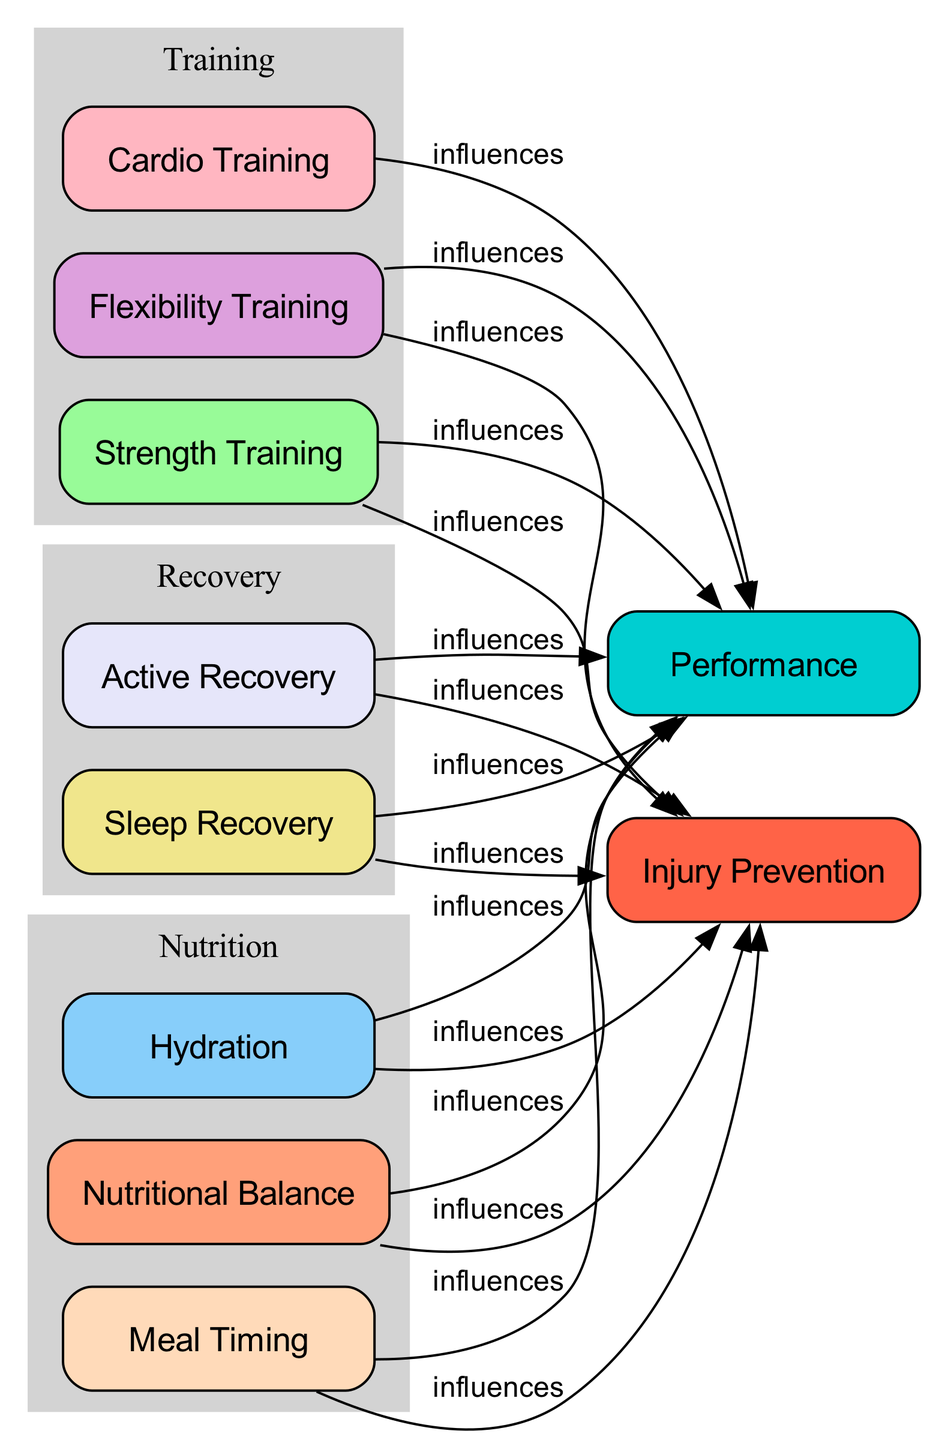What is the total number of nodes in the diagram? By counting each unique item listed under the nodes section, we find there are 10 distinct nodes representing various aspects of health and nutrition for athletes.
Answer: 10 Which node influences Performance the most? All nodes are connected to the Performance node; however, there is no node that influences it more than others as each node has a direct edge to it.
Answer: All nodes How many edges are directed towards Injury Prevention? I will count each directed edge leading into the Injury Prevention node from other nodes; there are 7 edges leading to it.
Answer: 7 What are the three types of training represented in the diagram? The diagram categorizes training types into Strength Training, Cardio Training, and Flexibility Training. These training types can be found within their designated subgraph in the diagram.
Answer: Strength Training, Cardio Training, Flexibility Training What is the relationship between Nutritional Balance and Injury Prevention? The directed edge from Nutritional Balance to Injury Prevention indicates that Nutritional Balance influences Injury Prevention directly within the context of the diagram.
Answer: influences How many nodes are related to Recovery? I can identify that there are 2 nodes specifically linked to Recovery in the diagram: Sleep Recovery and Active Recovery.
Answer: 2 Which node is related to both Performance and Injury Prevention? Nutritional Balance is the node that connects to both the Performance and Injury Prevention nodes through directed edges, showing its dual influence.
Answer: Nutritional Balance Which category do Meal Timing and Hydration belong to? Both Meal Timing and Hydration are part of the Nutrition subgraph in the diagram, indicating their focus on dietary aspects for athlete health.
Answer: Nutrition What do all edges in the diagram indicate? Each edge represents an influence, denoting a relationship where one node has a direct effect on another, simplifying the connections between dietary practices, training regimens, recovery methods, and performance outcomes.
Answer: influences 